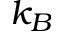<formula> <loc_0><loc_0><loc_500><loc_500>k _ { B }</formula> 